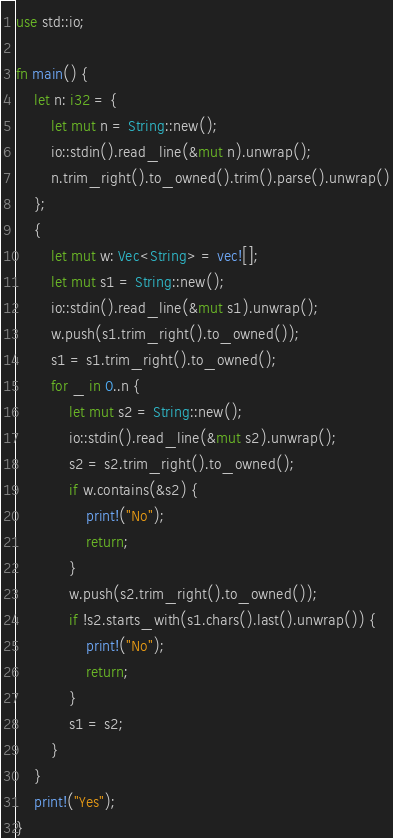Convert code to text. <code><loc_0><loc_0><loc_500><loc_500><_Rust_>use std::io;

fn main() {
    let n: i32 = {
        let mut n = String::new();
        io::stdin().read_line(&mut n).unwrap();
        n.trim_right().to_owned().trim().parse().unwrap()
    };
    {
        let mut w: Vec<String> = vec![];
        let mut s1 = String::new();
        io::stdin().read_line(&mut s1).unwrap();
        w.push(s1.trim_right().to_owned());
        s1 = s1.trim_right().to_owned();
        for _ in 0..n {
            let mut s2 = String::new();
            io::stdin().read_line(&mut s2).unwrap();
            s2 = s2.trim_right().to_owned();
            if w.contains(&s2) {
                print!("No");
                return;
            }
            w.push(s2.trim_right().to_owned());
            if !s2.starts_with(s1.chars().last().unwrap()) {
                print!("No");
                return;
            }
            s1 = s2;
        }
    }
    print!("Yes");
}
</code> 